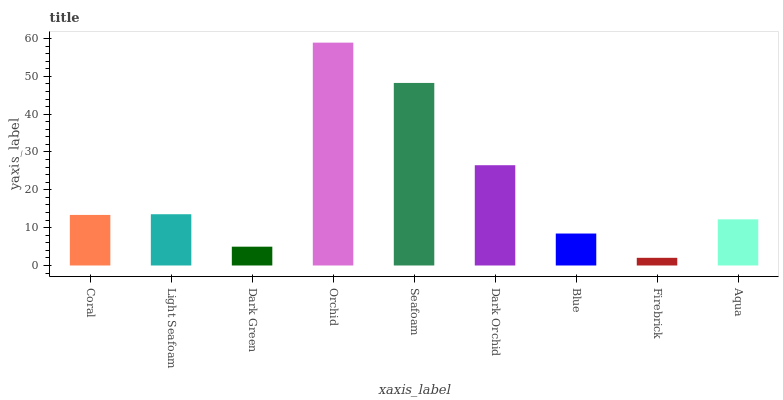Is Firebrick the minimum?
Answer yes or no. Yes. Is Orchid the maximum?
Answer yes or no. Yes. Is Light Seafoam the minimum?
Answer yes or no. No. Is Light Seafoam the maximum?
Answer yes or no. No. Is Light Seafoam greater than Coral?
Answer yes or no. Yes. Is Coral less than Light Seafoam?
Answer yes or no. Yes. Is Coral greater than Light Seafoam?
Answer yes or no. No. Is Light Seafoam less than Coral?
Answer yes or no. No. Is Coral the high median?
Answer yes or no. Yes. Is Coral the low median?
Answer yes or no. Yes. Is Blue the high median?
Answer yes or no. No. Is Aqua the low median?
Answer yes or no. No. 